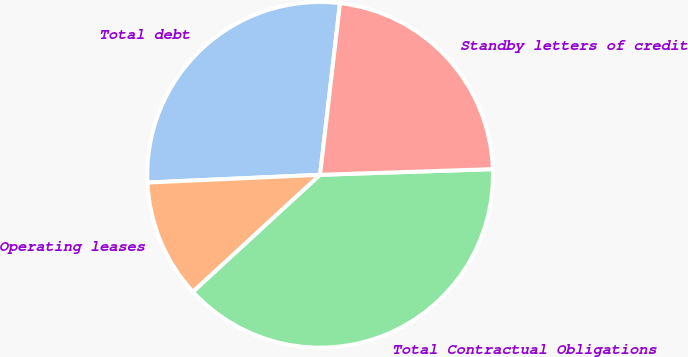Convert chart to OTSL. <chart><loc_0><loc_0><loc_500><loc_500><pie_chart><fcel>Total debt<fcel>Operating leases<fcel>Total Contractual Obligations<fcel>Standby letters of credit<nl><fcel>27.55%<fcel>11.13%<fcel>38.68%<fcel>22.64%<nl></chart> 